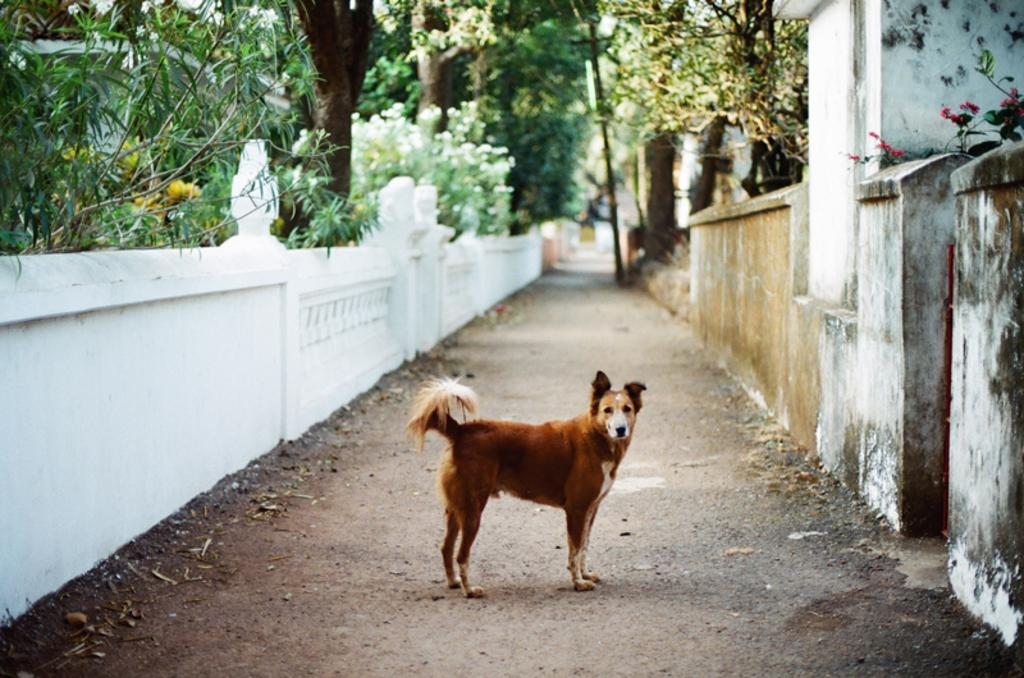What animal is standing in the image? There is a dog standing in the image. What can be seen in the background of the image? There are trees in the background of the image. What type of powder is the dog using to perform a trick in the image? There is no powder or trick present in the image; it simply shows a dog standing in front of trees. 